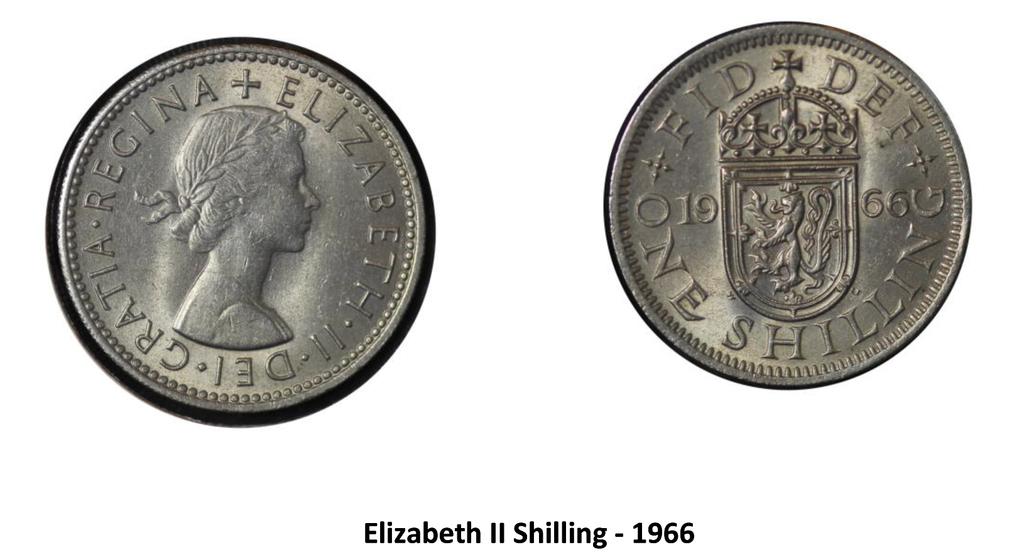What year is the coin from?
Provide a succinct answer. 1966. What is the value of the coin?
Offer a terse response. One shilling. 